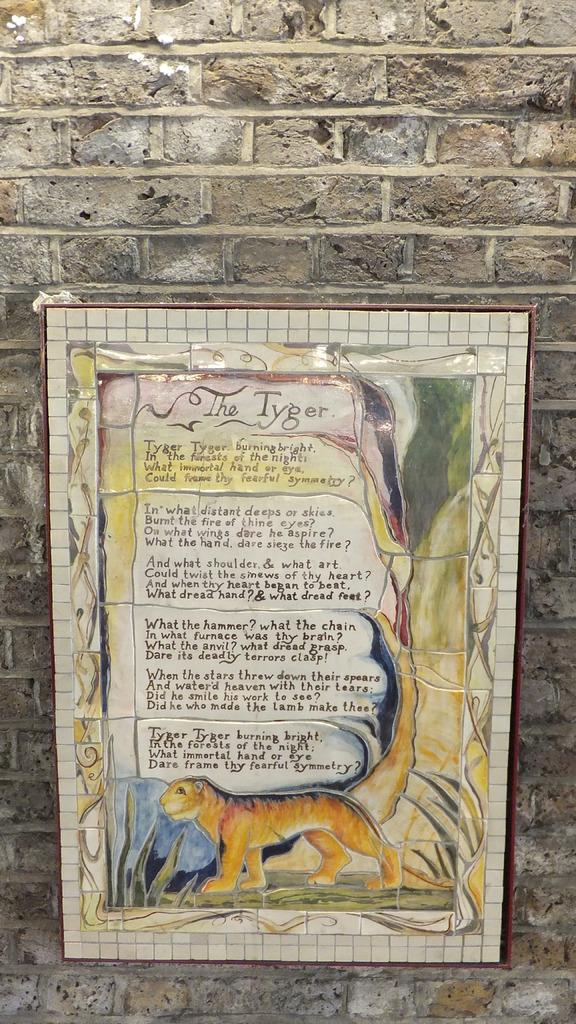What is present on the poster in the image? There is a poster in the image, and it contains text. What type of image is featured on the poster? The poster features an animal. What can be seen in the background of the image? There is a wall visible in the background of the image. What type of wax can be seen dripping from the bulb in the image? There is no wax or bulb present in the image; it only features a poster with an animal and text. How many plantations are visible in the image? There are no plantations visible in the image. 